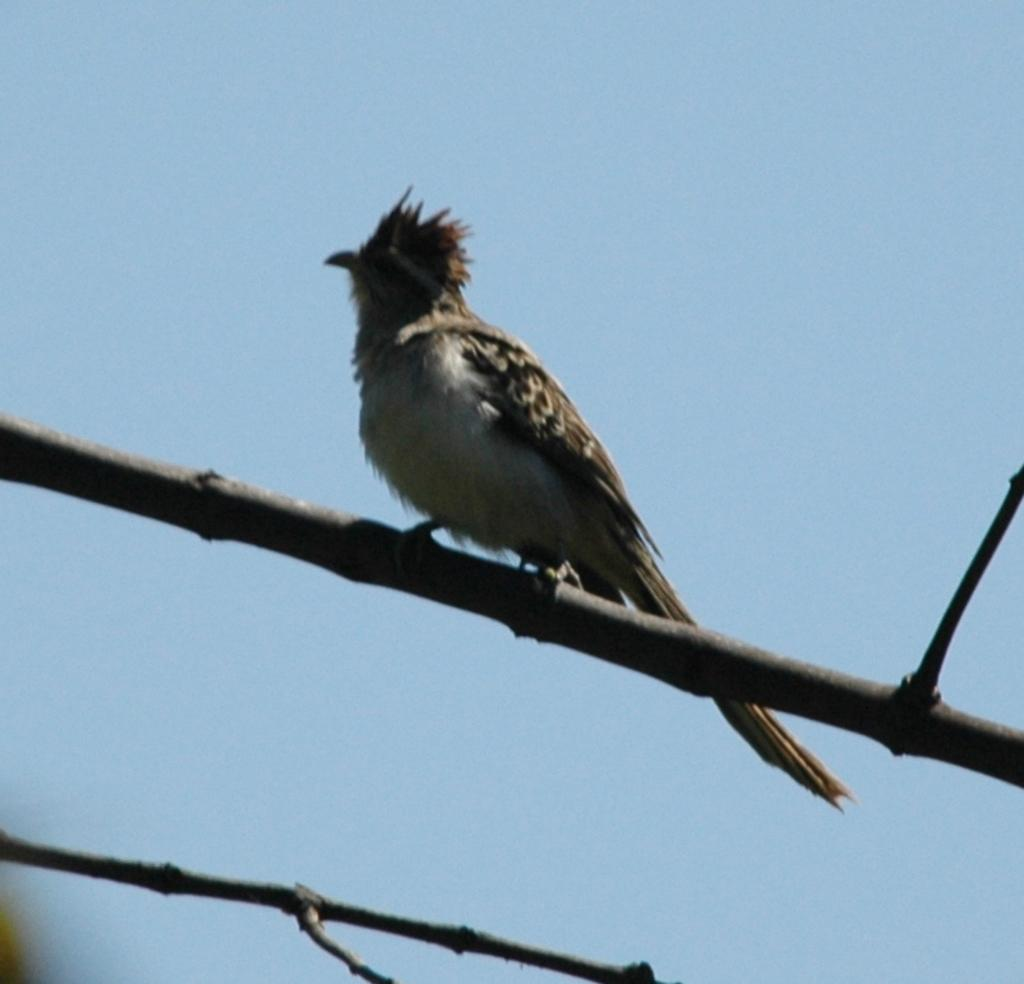What type of animal can be seen in the image? There is a bird in the image. Where is the bird located in the image? The bird is standing on a branch. What is the branch a part of? The branch is part of a tree. What can be seen in the background of the image? The sky is visible in the background of the image. What is the color of the sky in the image? The sky is blue in the image. How many units of sorting are being used by the bird in the image? There is no mention of sorting or units in the image, as it features a bird standing on a branch with a blue sky in the background. 